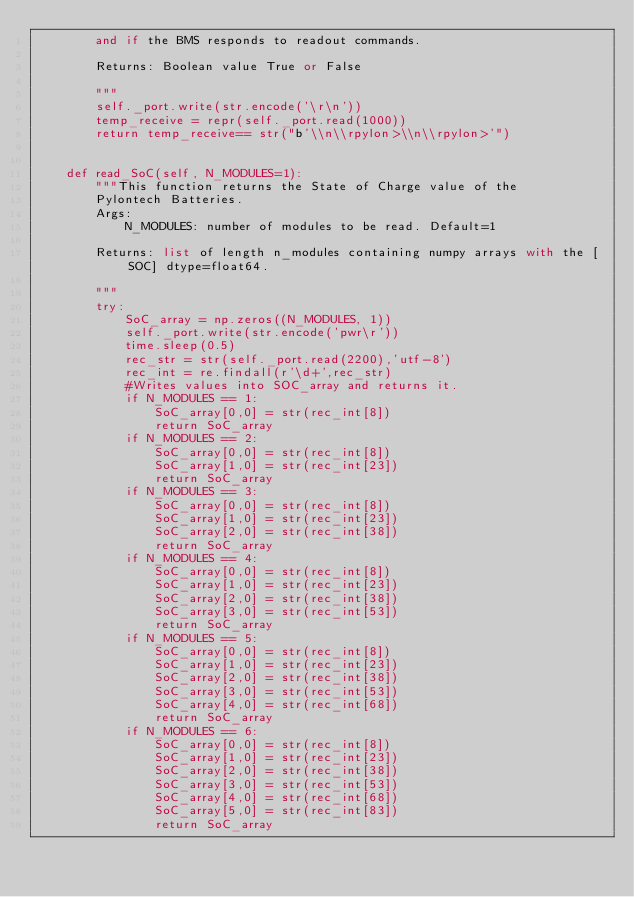<code> <loc_0><loc_0><loc_500><loc_500><_Python_>        and if the BMS responds to readout commands.

        Returns: Boolean value True or False

        """
        self._port.write(str.encode('\r\n'))
        temp_receive = repr(self._port.read(1000))
        return temp_receive== str("b'\\n\\rpylon>\\n\\rpylon>'")


    def read_SoC(self, N_MODULES=1):
        """This function returns the State of Charge value of the
        Pylontech Batteries.
        Args:
            N_MODULES: number of modules to be read. Default=1

        Returns: list of length n_modules containing numpy arrays with the [SOC] dtype=float64.

        """
        try:
            SoC_array = np.zeros((N_MODULES, 1))
            self._port.write(str.encode('pwr\r'))
            time.sleep(0.5)
            rec_str = str(self._port.read(2200),'utf-8')
            rec_int = re.findall(r'\d+',rec_str)
            #Writes values into SOC_array and returns it.
            if N_MODULES == 1:
                SoC_array[0,0] = str(rec_int[8])
                return SoC_array
            if N_MODULES == 2:
                SoC_array[0,0] = str(rec_int[8])
                SoC_array[1,0] = str(rec_int[23])
                return SoC_array
            if N_MODULES == 3:
                SoC_array[0,0] = str(rec_int[8])
                SoC_array[1,0] = str(rec_int[23])
                SoC_array[2,0] = str(rec_int[38])
                return SoC_array
            if N_MODULES == 4:
                SoC_array[0,0] = str(rec_int[8])
                SoC_array[1,0] = str(rec_int[23])
                SoC_array[2,0] = str(rec_int[38])
                SoC_array[3,0] = str(rec_int[53])
                return SoC_array
            if N_MODULES == 5:
                SoC_array[0,0] = str(rec_int[8])
                SoC_array[1,0] = str(rec_int[23])
                SoC_array[2,0] = str(rec_int[38])
                SoC_array[3,0] = str(rec_int[53])
                SoC_array[4,0] = str(rec_int[68])
                return SoC_array
            if N_MODULES == 6:
                SoC_array[0,0] = str(rec_int[8])
                SoC_array[1,0] = str(rec_int[23])
                SoC_array[2,0] = str(rec_int[38])
                SoC_array[3,0] = str(rec_int[53])
                SoC_array[4,0] = str(rec_int[68])
                SoC_array[5,0] = str(rec_int[83])
                return SoC_array</code> 